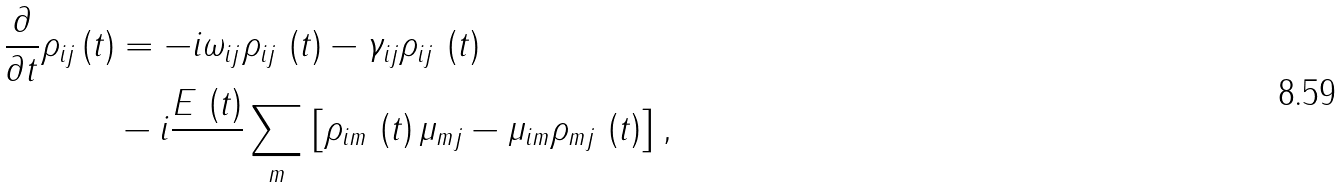<formula> <loc_0><loc_0><loc_500><loc_500>\frac { \partial } { \partial t } \rho _ { i j } \left ( t \right ) & = - i \omega _ { i j } \rho _ { i j } \, \left ( t \right ) - \gamma _ { i j } \rho _ { i j } \, \left ( t \right ) \\ & - i \frac { E \, \left ( t \right ) } { } \sum _ { m } \left [ \rho _ { i m } \, \left ( t \right ) \mu _ { m j } - \mu _ { i m } \rho _ { m j } \, \left ( t \right ) \right ] ,</formula> 